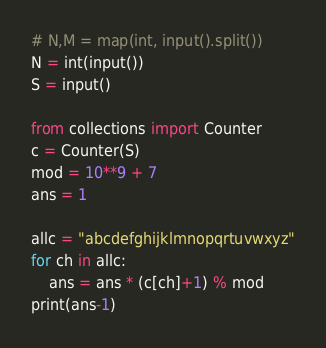Convert code to text. <code><loc_0><loc_0><loc_500><loc_500><_Python_># N,M = map(int, input().split())
N = int(input())
S = input()

from collections import Counter
c = Counter(S)
mod = 10**9 + 7
ans = 1

allc = "abcdefghijklmnopqrtuvwxyz"
for ch in allc:
    ans = ans * (c[ch]+1) % mod
print(ans-1)
</code> 